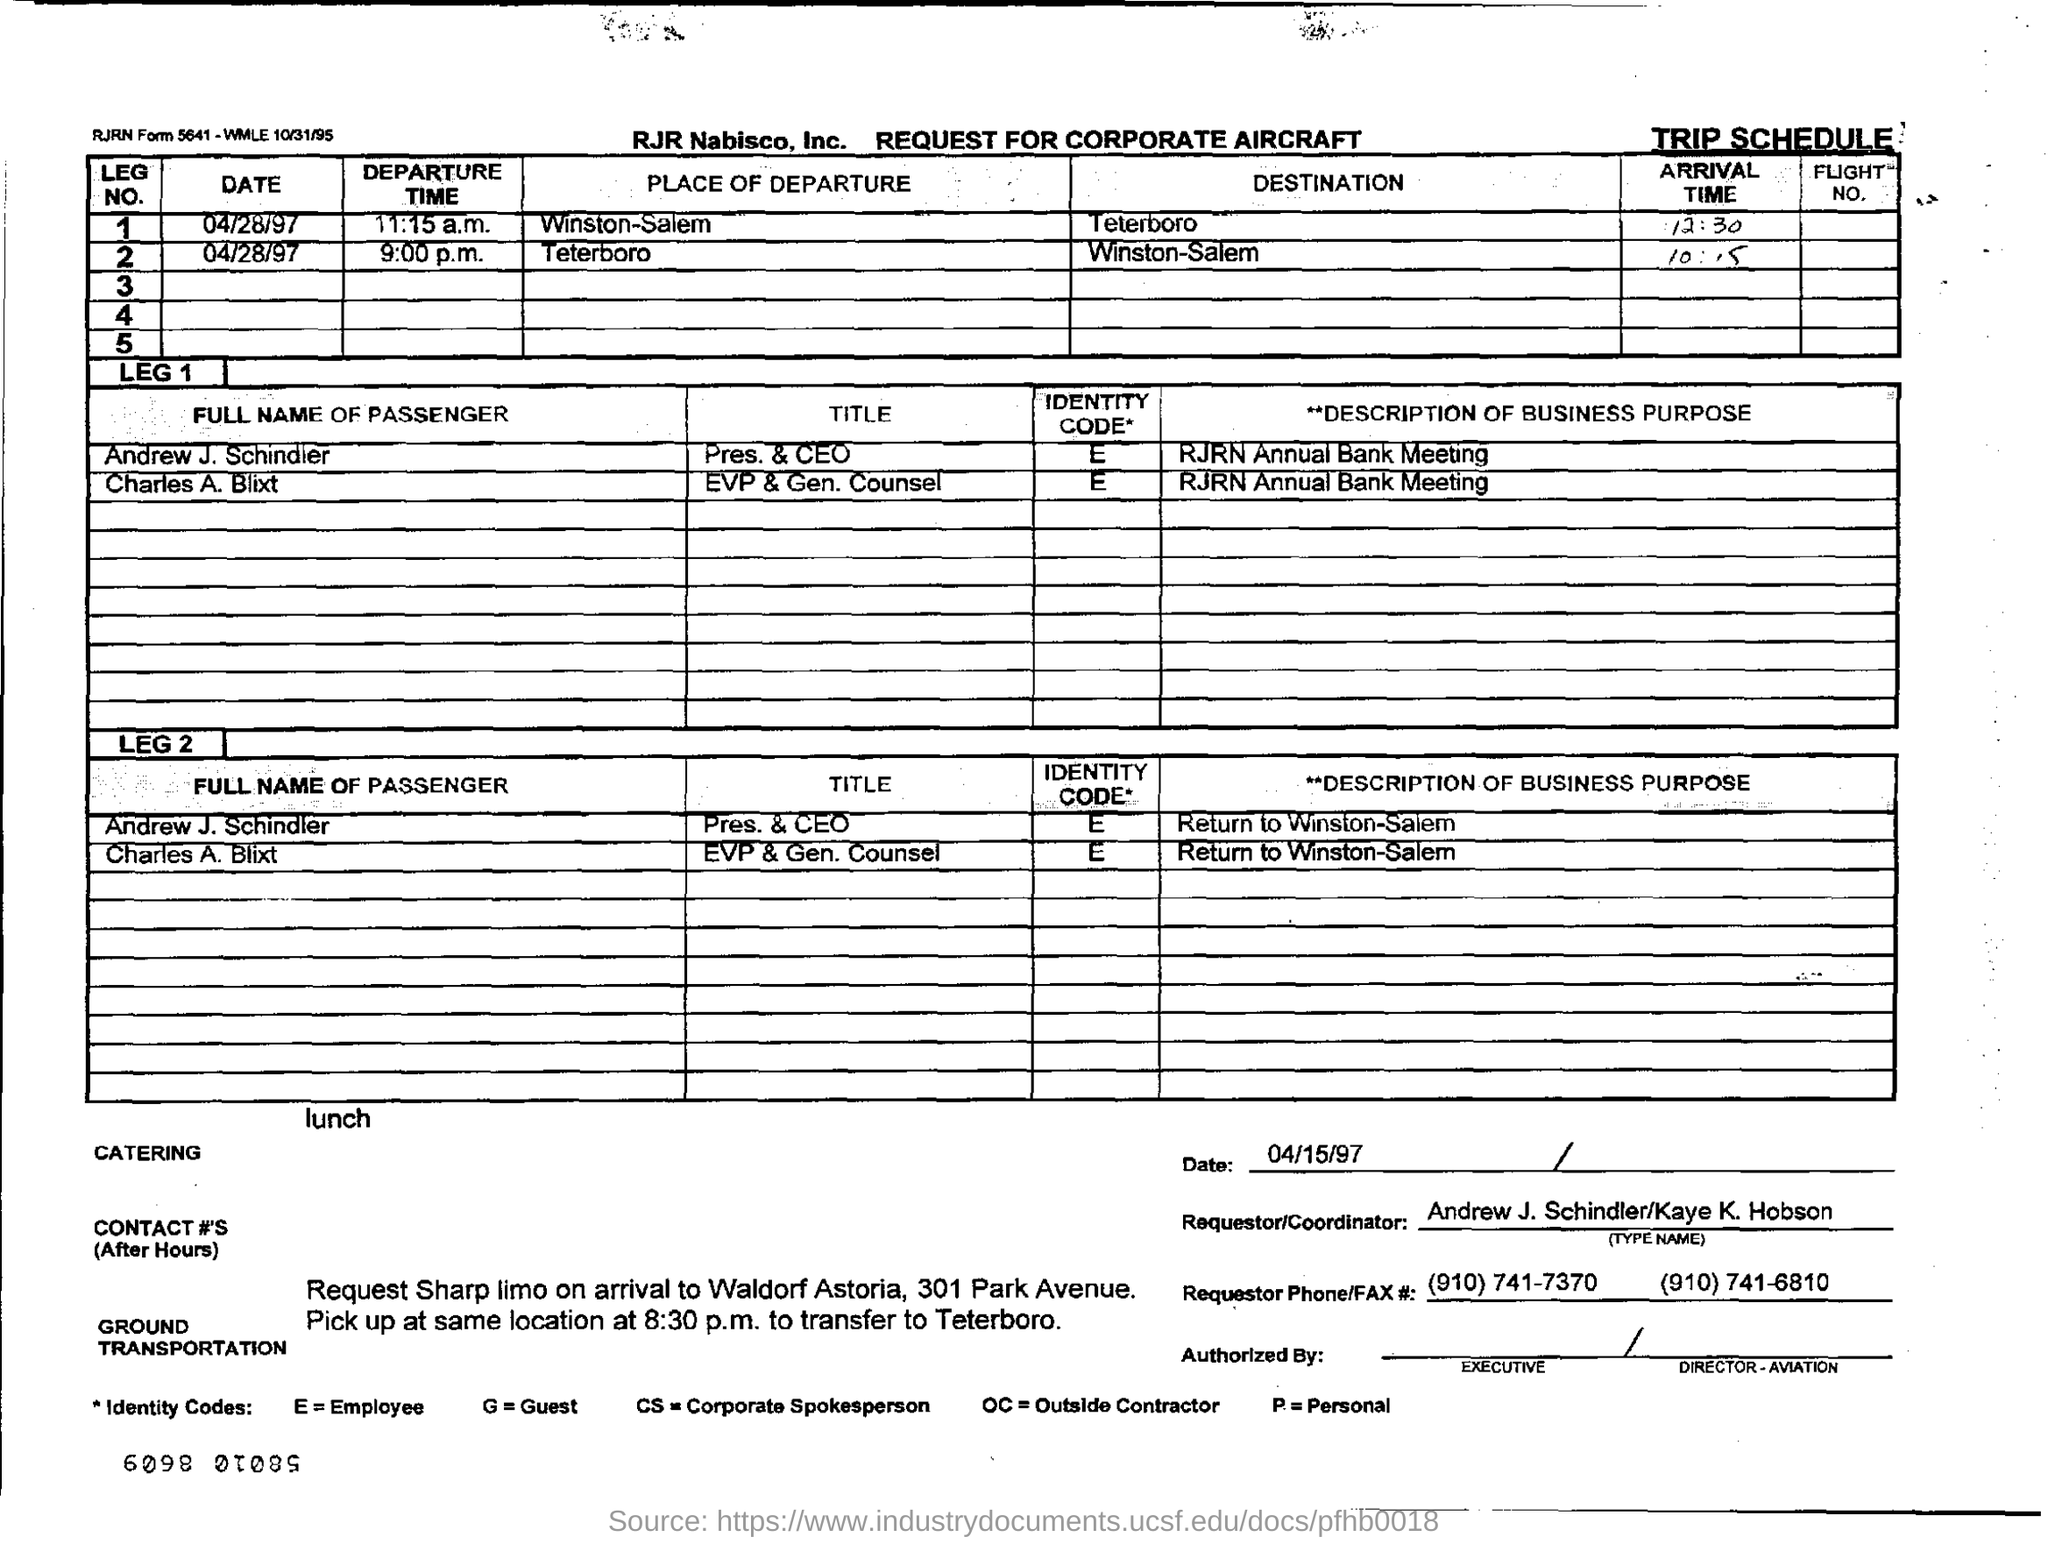Highlight a few significant elements in this photo. Charles A. Blixt is the executive vice president and general counsel of a company. I request a document title for corporate aircraft. Andrew J. Schindler is the President and CEO of a company or organization. The individual who is requesting or coordinating the subject of the sentence is Andrew J. Schindler or Kaye K. Hobson. 